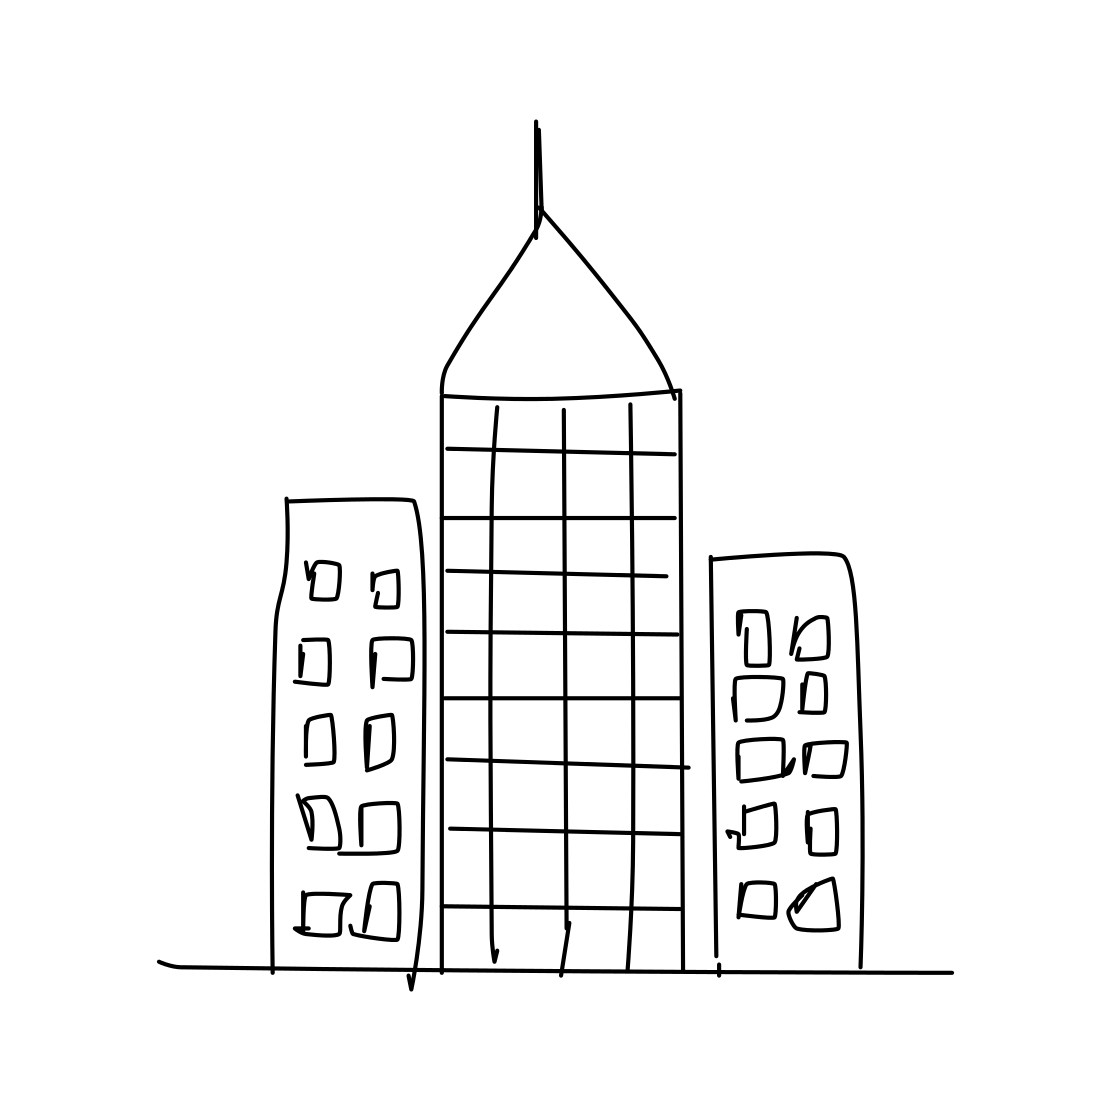What could this sketch represent in terms of city planning? This sketch could represent an early conceptual stage of city planning, where the size and placement of buildings are considered. The central skyscraper suggests a focus on commercial or business activities, while the smaller buildings might indicate residential or smaller business spaces. 